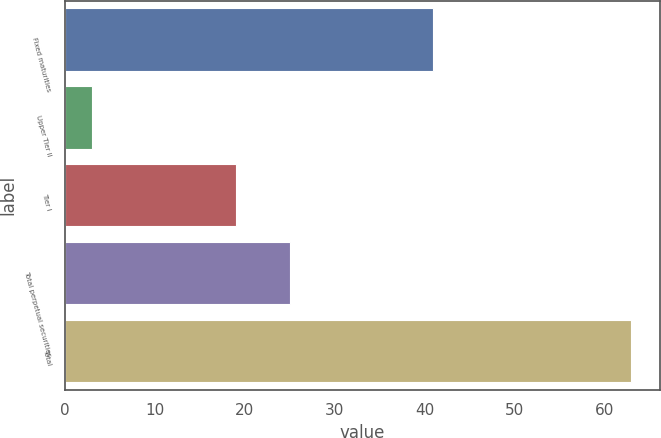<chart> <loc_0><loc_0><loc_500><loc_500><bar_chart><fcel>Fixed maturities<fcel>Upper Tier II<fcel>Tier I<fcel>Total perpetual securities<fcel>Total<nl><fcel>41<fcel>3<fcel>19<fcel>25<fcel>63<nl></chart> 